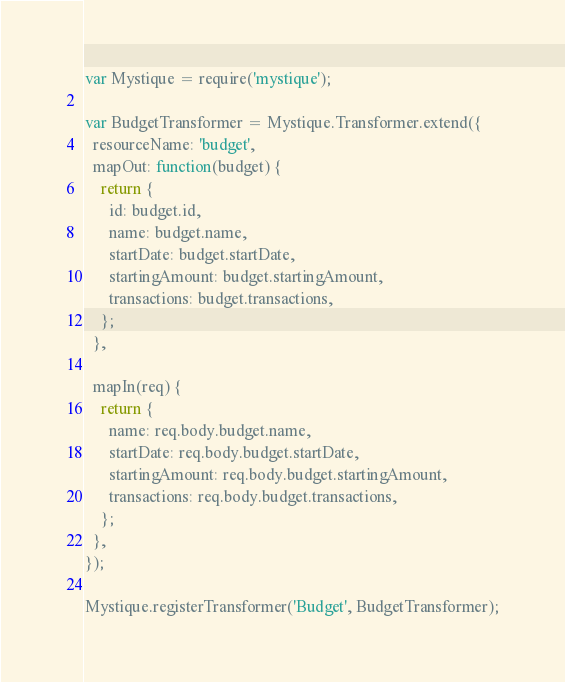<code> <loc_0><loc_0><loc_500><loc_500><_JavaScript_>var Mystique = require('mystique');

var BudgetTransformer = Mystique.Transformer.extend({
  resourceName: 'budget',
  mapOut: function(budget) {
    return {
      id: budget.id,
      name: budget.name,
      startDate: budget.startDate,
      startingAmount: budget.startingAmount,
      transactions: budget.transactions,
    };
  },

  mapIn(req) {
    return {
      name: req.body.budget.name,
      startDate: req.body.budget.startDate,
      startingAmount: req.body.budget.startingAmount,
      transactions: req.body.budget.transactions,
    };
  },
});

Mystique.registerTransformer('Budget', BudgetTransformer);
</code> 